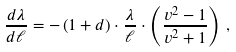Convert formula to latex. <formula><loc_0><loc_0><loc_500><loc_500>\frac { d \lambda } { d \ell } = - \left ( 1 + d \right ) \cdot \frac { \lambda } { \ell } \cdot \left ( \frac { v ^ { 2 } - 1 } { v ^ { 2 } + 1 } \right ) \, ,</formula> 